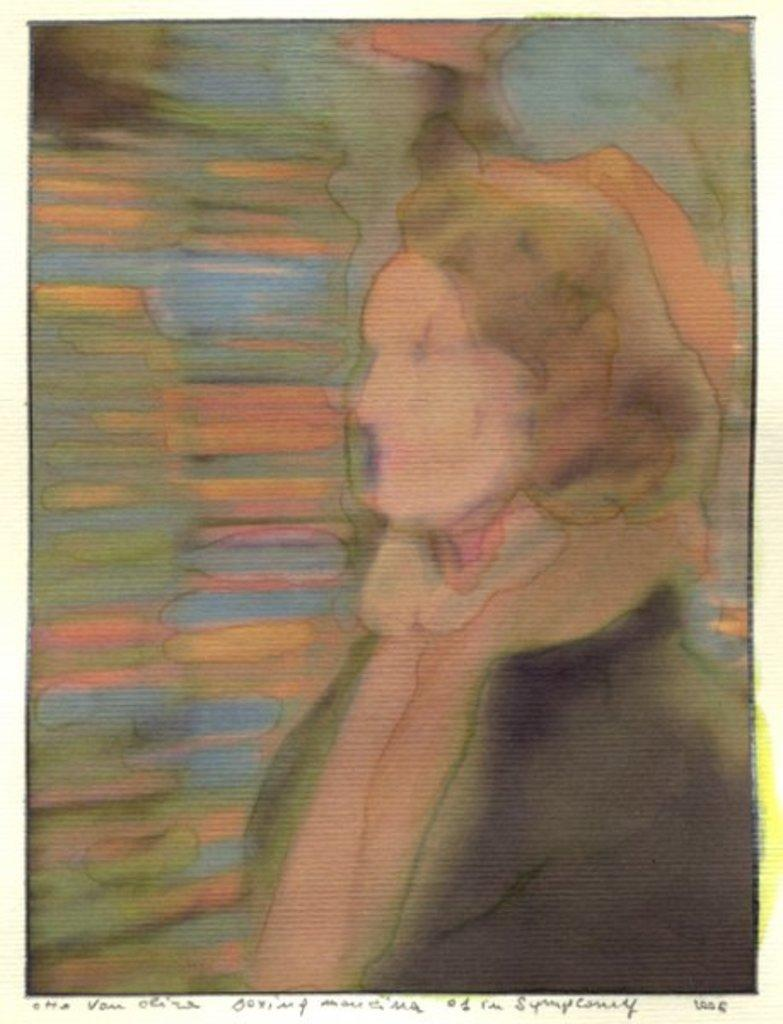What type of artwork is shown in the image? The image is a painting. What is the main subject of the painting? The painting depicts a lady. Is there any text present in the painting? Yes, there is text written at the bottom of the painting. What type of sweater is the farmer wearing in the painting? There is no farmer or sweater present in the painting; it depicts a lady. 